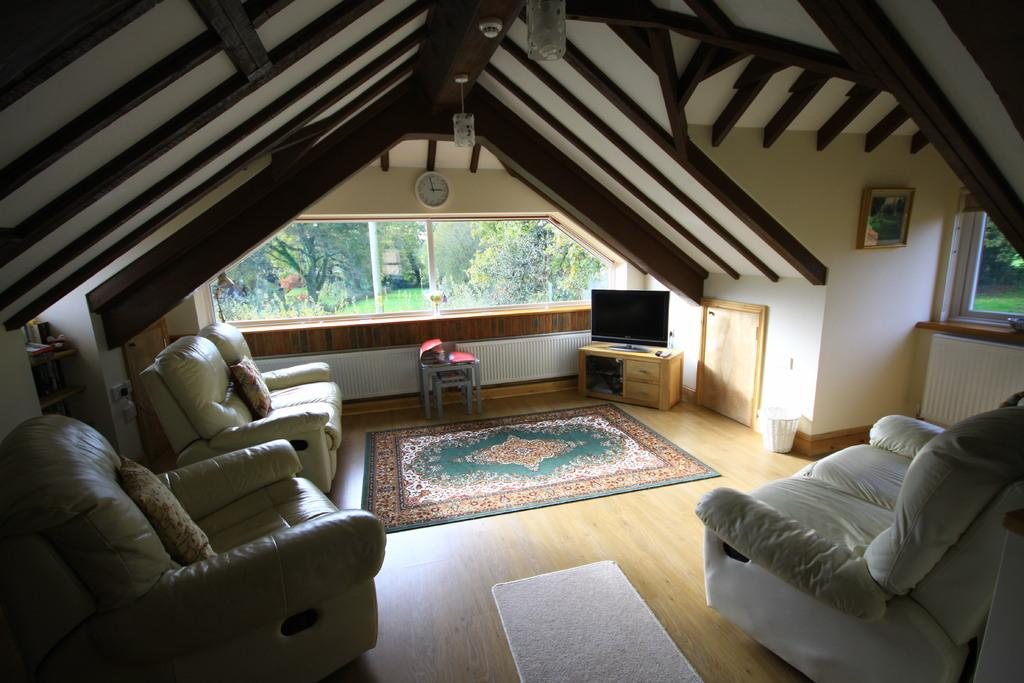Where is the setting of the image? The image is inside a room. What type of furniture is present in the room? There is a sofa in the room. What type of flooring is in the room? There is a carpet in the room. What type of entertainment device is in the room? There is a television in the room. What time-keeping device is in the room? There is a clock in the room. What type of window is in the room? There is a glass window in the room. What can be seen through the glass window? Trees are visible through the glass window. How many kittens are playing with a brick on the carpet in the image? There are no kittens or bricks present in the image. What type of berry is growing on the trees visible through the glass window? There is no mention of berries growing on the trees visible through the glass window in the image. 